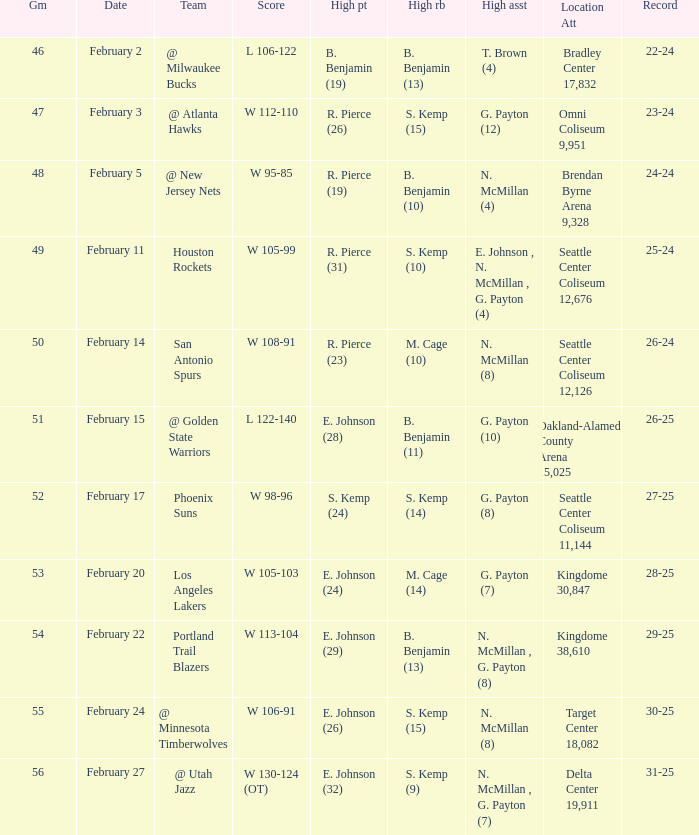What is the location and attendance for the game where b. benjamin (10) had the high rebounds? Brendan Byrne Arena 9,328. 